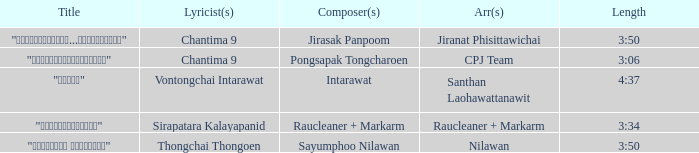Who was the arranger of "ขอโทษ"? Santhan Laohawattanawit. 